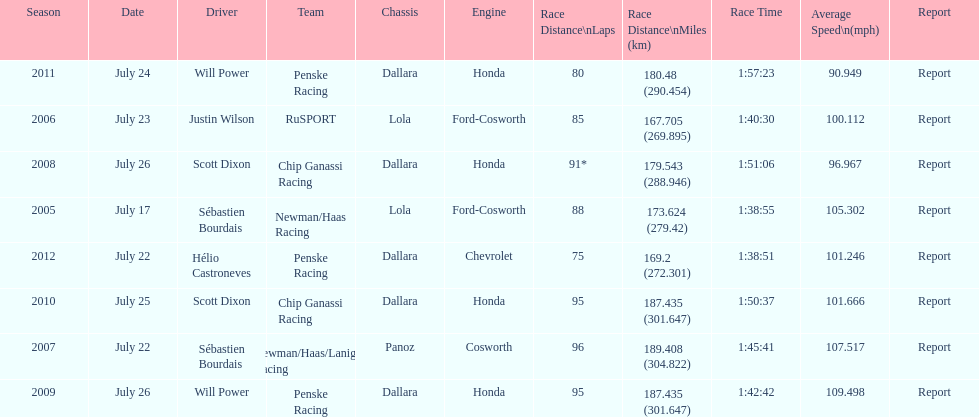Was the average speed in the year 2011 of the indycar series above or below the average speed of the year before? Below. 